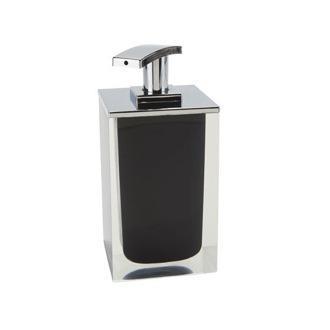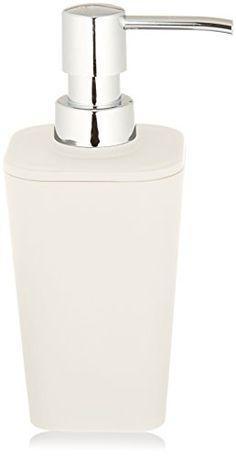The first image is the image on the left, the second image is the image on the right. Given the left and right images, does the statement "soap dispensers are made of stone material" hold true? Answer yes or no. No. The first image is the image on the left, the second image is the image on the right. Assess this claim about the two images: "The dispenser on the right is taller than the dispenser on the left.". Correct or not? Answer yes or no. Yes. 